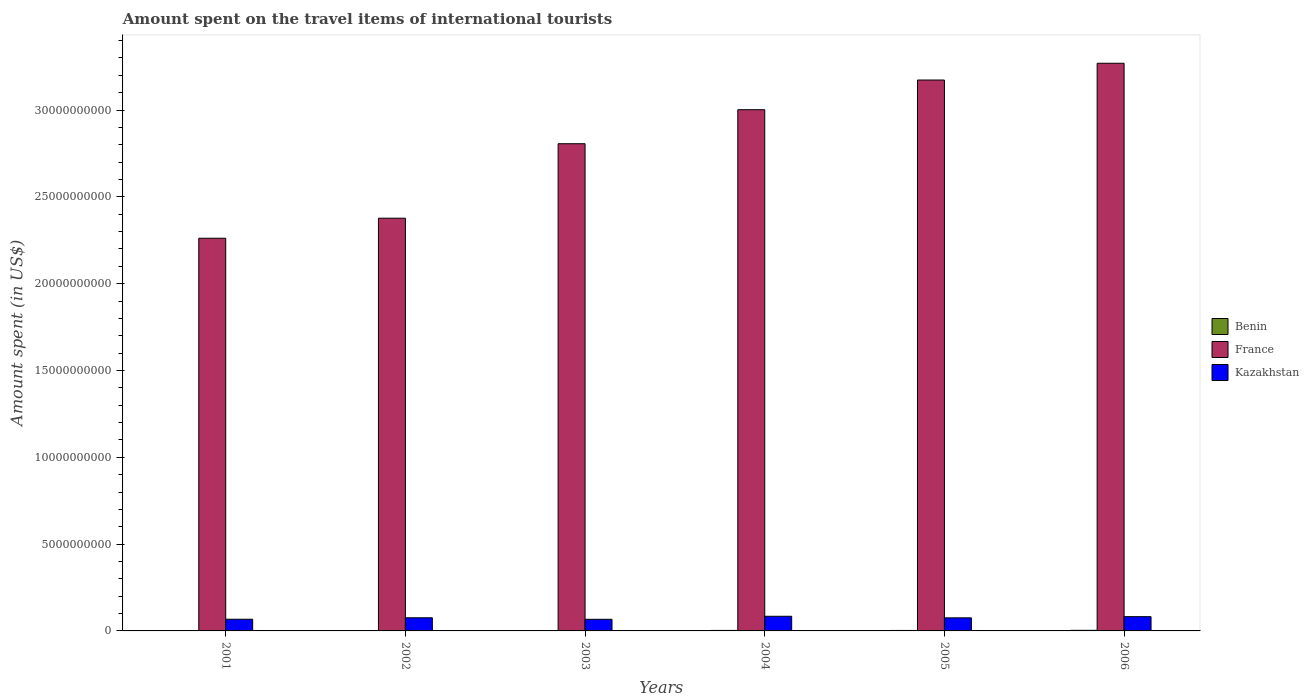How many groups of bars are there?
Provide a short and direct response. 6. Are the number of bars per tick equal to the number of legend labels?
Your answer should be compact. Yes. Are the number of bars on each tick of the X-axis equal?
Give a very brief answer. Yes. How many bars are there on the 3rd tick from the left?
Provide a succinct answer. 3. What is the label of the 2nd group of bars from the left?
Provide a short and direct response. 2002. In how many cases, is the number of bars for a given year not equal to the number of legend labels?
Make the answer very short. 0. What is the amount spent on the travel items of international tourists in France in 2002?
Make the answer very short. 2.38e+1. Across all years, what is the maximum amount spent on the travel items of international tourists in Kazakhstan?
Your answer should be very brief. 8.44e+08. Across all years, what is the minimum amount spent on the travel items of international tourists in Benin?
Provide a succinct answer. 1.70e+07. In which year was the amount spent on the travel items of international tourists in France minimum?
Ensure brevity in your answer.  2001. What is the total amount spent on the travel items of international tourists in Kazakhstan in the graph?
Offer a terse response. 4.52e+09. What is the difference between the amount spent on the travel items of international tourists in Benin in 2003 and that in 2004?
Offer a very short reply. -8.00e+06. What is the difference between the amount spent on the travel items of international tourists in Benin in 2005 and the amount spent on the travel items of international tourists in France in 2004?
Keep it short and to the point. -3.00e+1. What is the average amount spent on the travel items of international tourists in Kazakhstan per year?
Give a very brief answer. 7.53e+08. In the year 2005, what is the difference between the amount spent on the travel items of international tourists in Benin and amount spent on the travel items of international tourists in Kazakhstan?
Give a very brief answer. -7.26e+08. What is the ratio of the amount spent on the travel items of international tourists in France in 2001 to that in 2004?
Provide a short and direct response. 0.75. Is the amount spent on the travel items of international tourists in France in 2004 less than that in 2005?
Give a very brief answer. Yes. What is the difference between the highest and the second highest amount spent on the travel items of international tourists in Benin?
Make the answer very short. 5.00e+06. What is the difference between the highest and the lowest amount spent on the travel items of international tourists in Benin?
Offer a terse response. 1.70e+07. In how many years, is the amount spent on the travel items of international tourists in Benin greater than the average amount spent on the travel items of international tourists in Benin taken over all years?
Provide a short and direct response. 3. What does the 3rd bar from the left in 2003 represents?
Keep it short and to the point. Kazakhstan. What does the 1st bar from the right in 2004 represents?
Your response must be concise. Kazakhstan. How many bars are there?
Provide a short and direct response. 18. Are all the bars in the graph horizontal?
Your response must be concise. No. What is the difference between two consecutive major ticks on the Y-axis?
Give a very brief answer. 5.00e+09. Are the values on the major ticks of Y-axis written in scientific E-notation?
Provide a succinct answer. No. Does the graph contain any zero values?
Ensure brevity in your answer.  No. Does the graph contain grids?
Give a very brief answer. No. Where does the legend appear in the graph?
Provide a succinct answer. Center right. How many legend labels are there?
Keep it short and to the point. 3. What is the title of the graph?
Give a very brief answer. Amount spent on the travel items of international tourists. Does "Ireland" appear as one of the legend labels in the graph?
Give a very brief answer. No. What is the label or title of the Y-axis?
Your response must be concise. Amount spent (in US$). What is the Amount spent (in US$) of Benin in 2001?
Give a very brief answer. 1.70e+07. What is the Amount spent (in US$) of France in 2001?
Your answer should be compact. 2.26e+1. What is the Amount spent (in US$) in Kazakhstan in 2001?
Offer a terse response. 6.73e+08. What is the Amount spent (in US$) of France in 2002?
Make the answer very short. 2.38e+1. What is the Amount spent (in US$) of Kazakhstan in 2002?
Give a very brief answer. 7.57e+08. What is the Amount spent (in US$) in Benin in 2003?
Your response must be concise. 2.10e+07. What is the Amount spent (in US$) of France in 2003?
Your answer should be very brief. 2.81e+1. What is the Amount spent (in US$) of Kazakhstan in 2003?
Provide a succinct answer. 6.69e+08. What is the Amount spent (in US$) in Benin in 2004?
Your answer should be very brief. 2.90e+07. What is the Amount spent (in US$) of France in 2004?
Your answer should be compact. 3.00e+1. What is the Amount spent (in US$) in Kazakhstan in 2004?
Your response must be concise. 8.44e+08. What is the Amount spent (in US$) in Benin in 2005?
Your response must be concise. 2.70e+07. What is the Amount spent (in US$) of France in 2005?
Your answer should be compact. 3.17e+1. What is the Amount spent (in US$) of Kazakhstan in 2005?
Ensure brevity in your answer.  7.53e+08. What is the Amount spent (in US$) in Benin in 2006?
Provide a short and direct response. 3.40e+07. What is the Amount spent (in US$) of France in 2006?
Your answer should be very brief. 3.27e+1. What is the Amount spent (in US$) in Kazakhstan in 2006?
Provide a short and direct response. 8.21e+08. Across all years, what is the maximum Amount spent (in US$) of Benin?
Offer a very short reply. 3.40e+07. Across all years, what is the maximum Amount spent (in US$) of France?
Provide a succinct answer. 3.27e+1. Across all years, what is the maximum Amount spent (in US$) of Kazakhstan?
Give a very brief answer. 8.44e+08. Across all years, what is the minimum Amount spent (in US$) of Benin?
Provide a succinct answer. 1.70e+07. Across all years, what is the minimum Amount spent (in US$) in France?
Ensure brevity in your answer.  2.26e+1. Across all years, what is the minimum Amount spent (in US$) of Kazakhstan?
Give a very brief answer. 6.69e+08. What is the total Amount spent (in US$) of Benin in the graph?
Keep it short and to the point. 1.48e+08. What is the total Amount spent (in US$) of France in the graph?
Give a very brief answer. 1.69e+11. What is the total Amount spent (in US$) in Kazakhstan in the graph?
Offer a terse response. 4.52e+09. What is the difference between the Amount spent (in US$) of Benin in 2001 and that in 2002?
Your answer should be very brief. -3.00e+06. What is the difference between the Amount spent (in US$) of France in 2001 and that in 2002?
Keep it short and to the point. -1.15e+09. What is the difference between the Amount spent (in US$) in Kazakhstan in 2001 and that in 2002?
Offer a very short reply. -8.40e+07. What is the difference between the Amount spent (in US$) in France in 2001 and that in 2003?
Offer a terse response. -5.44e+09. What is the difference between the Amount spent (in US$) in Benin in 2001 and that in 2004?
Your response must be concise. -1.20e+07. What is the difference between the Amount spent (in US$) of France in 2001 and that in 2004?
Ensure brevity in your answer.  -7.40e+09. What is the difference between the Amount spent (in US$) in Kazakhstan in 2001 and that in 2004?
Ensure brevity in your answer.  -1.71e+08. What is the difference between the Amount spent (in US$) in Benin in 2001 and that in 2005?
Provide a short and direct response. -1.00e+07. What is the difference between the Amount spent (in US$) of France in 2001 and that in 2005?
Provide a succinct answer. -9.11e+09. What is the difference between the Amount spent (in US$) of Kazakhstan in 2001 and that in 2005?
Provide a succinct answer. -8.00e+07. What is the difference between the Amount spent (in US$) of Benin in 2001 and that in 2006?
Your answer should be very brief. -1.70e+07. What is the difference between the Amount spent (in US$) of France in 2001 and that in 2006?
Offer a very short reply. -1.01e+1. What is the difference between the Amount spent (in US$) in Kazakhstan in 2001 and that in 2006?
Your answer should be compact. -1.48e+08. What is the difference between the Amount spent (in US$) of France in 2002 and that in 2003?
Make the answer very short. -4.29e+09. What is the difference between the Amount spent (in US$) of Kazakhstan in 2002 and that in 2003?
Provide a succinct answer. 8.80e+07. What is the difference between the Amount spent (in US$) in Benin in 2002 and that in 2004?
Your answer should be compact. -9.00e+06. What is the difference between the Amount spent (in US$) in France in 2002 and that in 2004?
Give a very brief answer. -6.25e+09. What is the difference between the Amount spent (in US$) in Kazakhstan in 2002 and that in 2004?
Your answer should be compact. -8.70e+07. What is the difference between the Amount spent (in US$) in Benin in 2002 and that in 2005?
Your answer should be compact. -7.00e+06. What is the difference between the Amount spent (in US$) of France in 2002 and that in 2005?
Provide a succinct answer. -7.96e+09. What is the difference between the Amount spent (in US$) of Kazakhstan in 2002 and that in 2005?
Your response must be concise. 4.00e+06. What is the difference between the Amount spent (in US$) of Benin in 2002 and that in 2006?
Provide a succinct answer. -1.40e+07. What is the difference between the Amount spent (in US$) of France in 2002 and that in 2006?
Provide a short and direct response. -8.92e+09. What is the difference between the Amount spent (in US$) of Kazakhstan in 2002 and that in 2006?
Ensure brevity in your answer.  -6.40e+07. What is the difference between the Amount spent (in US$) of Benin in 2003 and that in 2004?
Provide a succinct answer. -8.00e+06. What is the difference between the Amount spent (in US$) in France in 2003 and that in 2004?
Provide a succinct answer. -1.96e+09. What is the difference between the Amount spent (in US$) of Kazakhstan in 2003 and that in 2004?
Your response must be concise. -1.75e+08. What is the difference between the Amount spent (in US$) in Benin in 2003 and that in 2005?
Provide a succinct answer. -6.00e+06. What is the difference between the Amount spent (in US$) of France in 2003 and that in 2005?
Give a very brief answer. -3.67e+09. What is the difference between the Amount spent (in US$) of Kazakhstan in 2003 and that in 2005?
Your answer should be compact. -8.40e+07. What is the difference between the Amount spent (in US$) in Benin in 2003 and that in 2006?
Provide a succinct answer. -1.30e+07. What is the difference between the Amount spent (in US$) of France in 2003 and that in 2006?
Your response must be concise. -4.63e+09. What is the difference between the Amount spent (in US$) in Kazakhstan in 2003 and that in 2006?
Ensure brevity in your answer.  -1.52e+08. What is the difference between the Amount spent (in US$) of France in 2004 and that in 2005?
Ensure brevity in your answer.  -1.71e+09. What is the difference between the Amount spent (in US$) of Kazakhstan in 2004 and that in 2005?
Your response must be concise. 9.10e+07. What is the difference between the Amount spent (in US$) of Benin in 2004 and that in 2006?
Give a very brief answer. -5.00e+06. What is the difference between the Amount spent (in US$) of France in 2004 and that in 2006?
Give a very brief answer. -2.68e+09. What is the difference between the Amount spent (in US$) in Kazakhstan in 2004 and that in 2006?
Your answer should be compact. 2.30e+07. What is the difference between the Amount spent (in US$) in Benin in 2005 and that in 2006?
Keep it short and to the point. -7.00e+06. What is the difference between the Amount spent (in US$) in France in 2005 and that in 2006?
Provide a short and direct response. -9.66e+08. What is the difference between the Amount spent (in US$) in Kazakhstan in 2005 and that in 2006?
Make the answer very short. -6.80e+07. What is the difference between the Amount spent (in US$) of Benin in 2001 and the Amount spent (in US$) of France in 2002?
Keep it short and to the point. -2.38e+1. What is the difference between the Amount spent (in US$) of Benin in 2001 and the Amount spent (in US$) of Kazakhstan in 2002?
Your response must be concise. -7.40e+08. What is the difference between the Amount spent (in US$) in France in 2001 and the Amount spent (in US$) in Kazakhstan in 2002?
Ensure brevity in your answer.  2.19e+1. What is the difference between the Amount spent (in US$) of Benin in 2001 and the Amount spent (in US$) of France in 2003?
Your answer should be very brief. -2.80e+1. What is the difference between the Amount spent (in US$) of Benin in 2001 and the Amount spent (in US$) of Kazakhstan in 2003?
Provide a succinct answer. -6.52e+08. What is the difference between the Amount spent (in US$) in France in 2001 and the Amount spent (in US$) in Kazakhstan in 2003?
Ensure brevity in your answer.  2.19e+1. What is the difference between the Amount spent (in US$) in Benin in 2001 and the Amount spent (in US$) in France in 2004?
Provide a short and direct response. -3.00e+1. What is the difference between the Amount spent (in US$) in Benin in 2001 and the Amount spent (in US$) in Kazakhstan in 2004?
Offer a terse response. -8.27e+08. What is the difference between the Amount spent (in US$) in France in 2001 and the Amount spent (in US$) in Kazakhstan in 2004?
Offer a terse response. 2.18e+1. What is the difference between the Amount spent (in US$) of Benin in 2001 and the Amount spent (in US$) of France in 2005?
Your response must be concise. -3.17e+1. What is the difference between the Amount spent (in US$) in Benin in 2001 and the Amount spent (in US$) in Kazakhstan in 2005?
Your answer should be very brief. -7.36e+08. What is the difference between the Amount spent (in US$) in France in 2001 and the Amount spent (in US$) in Kazakhstan in 2005?
Your answer should be compact. 2.19e+1. What is the difference between the Amount spent (in US$) in Benin in 2001 and the Amount spent (in US$) in France in 2006?
Provide a short and direct response. -3.27e+1. What is the difference between the Amount spent (in US$) of Benin in 2001 and the Amount spent (in US$) of Kazakhstan in 2006?
Make the answer very short. -8.04e+08. What is the difference between the Amount spent (in US$) of France in 2001 and the Amount spent (in US$) of Kazakhstan in 2006?
Ensure brevity in your answer.  2.18e+1. What is the difference between the Amount spent (in US$) of Benin in 2002 and the Amount spent (in US$) of France in 2003?
Provide a short and direct response. -2.80e+1. What is the difference between the Amount spent (in US$) of Benin in 2002 and the Amount spent (in US$) of Kazakhstan in 2003?
Make the answer very short. -6.49e+08. What is the difference between the Amount spent (in US$) of France in 2002 and the Amount spent (in US$) of Kazakhstan in 2003?
Your response must be concise. 2.31e+1. What is the difference between the Amount spent (in US$) in Benin in 2002 and the Amount spent (in US$) in France in 2004?
Make the answer very short. -3.00e+1. What is the difference between the Amount spent (in US$) of Benin in 2002 and the Amount spent (in US$) of Kazakhstan in 2004?
Your answer should be very brief. -8.24e+08. What is the difference between the Amount spent (in US$) in France in 2002 and the Amount spent (in US$) in Kazakhstan in 2004?
Make the answer very short. 2.29e+1. What is the difference between the Amount spent (in US$) of Benin in 2002 and the Amount spent (in US$) of France in 2005?
Your answer should be very brief. -3.17e+1. What is the difference between the Amount spent (in US$) of Benin in 2002 and the Amount spent (in US$) of Kazakhstan in 2005?
Offer a very short reply. -7.33e+08. What is the difference between the Amount spent (in US$) in France in 2002 and the Amount spent (in US$) in Kazakhstan in 2005?
Your answer should be compact. 2.30e+1. What is the difference between the Amount spent (in US$) of Benin in 2002 and the Amount spent (in US$) of France in 2006?
Provide a short and direct response. -3.27e+1. What is the difference between the Amount spent (in US$) of Benin in 2002 and the Amount spent (in US$) of Kazakhstan in 2006?
Offer a very short reply. -8.01e+08. What is the difference between the Amount spent (in US$) in France in 2002 and the Amount spent (in US$) in Kazakhstan in 2006?
Make the answer very short. 2.29e+1. What is the difference between the Amount spent (in US$) of Benin in 2003 and the Amount spent (in US$) of France in 2004?
Your answer should be compact. -3.00e+1. What is the difference between the Amount spent (in US$) in Benin in 2003 and the Amount spent (in US$) in Kazakhstan in 2004?
Ensure brevity in your answer.  -8.23e+08. What is the difference between the Amount spent (in US$) in France in 2003 and the Amount spent (in US$) in Kazakhstan in 2004?
Provide a short and direct response. 2.72e+1. What is the difference between the Amount spent (in US$) of Benin in 2003 and the Amount spent (in US$) of France in 2005?
Your answer should be very brief. -3.17e+1. What is the difference between the Amount spent (in US$) in Benin in 2003 and the Amount spent (in US$) in Kazakhstan in 2005?
Give a very brief answer. -7.32e+08. What is the difference between the Amount spent (in US$) of France in 2003 and the Amount spent (in US$) of Kazakhstan in 2005?
Your answer should be very brief. 2.73e+1. What is the difference between the Amount spent (in US$) in Benin in 2003 and the Amount spent (in US$) in France in 2006?
Make the answer very short. -3.27e+1. What is the difference between the Amount spent (in US$) in Benin in 2003 and the Amount spent (in US$) in Kazakhstan in 2006?
Ensure brevity in your answer.  -8.00e+08. What is the difference between the Amount spent (in US$) of France in 2003 and the Amount spent (in US$) of Kazakhstan in 2006?
Offer a terse response. 2.72e+1. What is the difference between the Amount spent (in US$) in Benin in 2004 and the Amount spent (in US$) in France in 2005?
Your answer should be compact. -3.17e+1. What is the difference between the Amount spent (in US$) in Benin in 2004 and the Amount spent (in US$) in Kazakhstan in 2005?
Your answer should be very brief. -7.24e+08. What is the difference between the Amount spent (in US$) of France in 2004 and the Amount spent (in US$) of Kazakhstan in 2005?
Your answer should be compact. 2.93e+1. What is the difference between the Amount spent (in US$) in Benin in 2004 and the Amount spent (in US$) in France in 2006?
Your answer should be compact. -3.27e+1. What is the difference between the Amount spent (in US$) in Benin in 2004 and the Amount spent (in US$) in Kazakhstan in 2006?
Your response must be concise. -7.92e+08. What is the difference between the Amount spent (in US$) of France in 2004 and the Amount spent (in US$) of Kazakhstan in 2006?
Offer a terse response. 2.92e+1. What is the difference between the Amount spent (in US$) in Benin in 2005 and the Amount spent (in US$) in France in 2006?
Your answer should be very brief. -3.27e+1. What is the difference between the Amount spent (in US$) of Benin in 2005 and the Amount spent (in US$) of Kazakhstan in 2006?
Your answer should be very brief. -7.94e+08. What is the difference between the Amount spent (in US$) of France in 2005 and the Amount spent (in US$) of Kazakhstan in 2006?
Provide a short and direct response. 3.09e+1. What is the average Amount spent (in US$) in Benin per year?
Your answer should be very brief. 2.47e+07. What is the average Amount spent (in US$) of France per year?
Ensure brevity in your answer.  2.81e+1. What is the average Amount spent (in US$) of Kazakhstan per year?
Offer a terse response. 7.53e+08. In the year 2001, what is the difference between the Amount spent (in US$) in Benin and Amount spent (in US$) in France?
Offer a very short reply. -2.26e+1. In the year 2001, what is the difference between the Amount spent (in US$) of Benin and Amount spent (in US$) of Kazakhstan?
Keep it short and to the point. -6.56e+08. In the year 2001, what is the difference between the Amount spent (in US$) of France and Amount spent (in US$) of Kazakhstan?
Your answer should be compact. 2.19e+1. In the year 2002, what is the difference between the Amount spent (in US$) of Benin and Amount spent (in US$) of France?
Your response must be concise. -2.37e+1. In the year 2002, what is the difference between the Amount spent (in US$) in Benin and Amount spent (in US$) in Kazakhstan?
Make the answer very short. -7.37e+08. In the year 2002, what is the difference between the Amount spent (in US$) in France and Amount spent (in US$) in Kazakhstan?
Offer a terse response. 2.30e+1. In the year 2003, what is the difference between the Amount spent (in US$) in Benin and Amount spent (in US$) in France?
Provide a succinct answer. -2.80e+1. In the year 2003, what is the difference between the Amount spent (in US$) in Benin and Amount spent (in US$) in Kazakhstan?
Your answer should be compact. -6.48e+08. In the year 2003, what is the difference between the Amount spent (in US$) in France and Amount spent (in US$) in Kazakhstan?
Provide a short and direct response. 2.74e+1. In the year 2004, what is the difference between the Amount spent (in US$) in Benin and Amount spent (in US$) in France?
Provide a succinct answer. -3.00e+1. In the year 2004, what is the difference between the Amount spent (in US$) of Benin and Amount spent (in US$) of Kazakhstan?
Give a very brief answer. -8.15e+08. In the year 2004, what is the difference between the Amount spent (in US$) in France and Amount spent (in US$) in Kazakhstan?
Keep it short and to the point. 2.92e+1. In the year 2005, what is the difference between the Amount spent (in US$) in Benin and Amount spent (in US$) in France?
Provide a short and direct response. -3.17e+1. In the year 2005, what is the difference between the Amount spent (in US$) of Benin and Amount spent (in US$) of Kazakhstan?
Offer a very short reply. -7.26e+08. In the year 2005, what is the difference between the Amount spent (in US$) in France and Amount spent (in US$) in Kazakhstan?
Offer a terse response. 3.10e+1. In the year 2006, what is the difference between the Amount spent (in US$) of Benin and Amount spent (in US$) of France?
Provide a succinct answer. -3.27e+1. In the year 2006, what is the difference between the Amount spent (in US$) of Benin and Amount spent (in US$) of Kazakhstan?
Make the answer very short. -7.87e+08. In the year 2006, what is the difference between the Amount spent (in US$) in France and Amount spent (in US$) in Kazakhstan?
Keep it short and to the point. 3.19e+1. What is the ratio of the Amount spent (in US$) in Benin in 2001 to that in 2002?
Your answer should be compact. 0.85. What is the ratio of the Amount spent (in US$) in France in 2001 to that in 2002?
Keep it short and to the point. 0.95. What is the ratio of the Amount spent (in US$) of Kazakhstan in 2001 to that in 2002?
Your answer should be very brief. 0.89. What is the ratio of the Amount spent (in US$) in Benin in 2001 to that in 2003?
Your answer should be compact. 0.81. What is the ratio of the Amount spent (in US$) in France in 2001 to that in 2003?
Your response must be concise. 0.81. What is the ratio of the Amount spent (in US$) of Benin in 2001 to that in 2004?
Offer a very short reply. 0.59. What is the ratio of the Amount spent (in US$) of France in 2001 to that in 2004?
Your answer should be very brief. 0.75. What is the ratio of the Amount spent (in US$) of Kazakhstan in 2001 to that in 2004?
Provide a succinct answer. 0.8. What is the ratio of the Amount spent (in US$) of Benin in 2001 to that in 2005?
Provide a short and direct response. 0.63. What is the ratio of the Amount spent (in US$) in France in 2001 to that in 2005?
Offer a very short reply. 0.71. What is the ratio of the Amount spent (in US$) in Kazakhstan in 2001 to that in 2005?
Your response must be concise. 0.89. What is the ratio of the Amount spent (in US$) in France in 2001 to that in 2006?
Give a very brief answer. 0.69. What is the ratio of the Amount spent (in US$) of Kazakhstan in 2001 to that in 2006?
Ensure brevity in your answer.  0.82. What is the ratio of the Amount spent (in US$) in France in 2002 to that in 2003?
Provide a succinct answer. 0.85. What is the ratio of the Amount spent (in US$) in Kazakhstan in 2002 to that in 2003?
Your answer should be very brief. 1.13. What is the ratio of the Amount spent (in US$) of Benin in 2002 to that in 2004?
Your response must be concise. 0.69. What is the ratio of the Amount spent (in US$) of France in 2002 to that in 2004?
Offer a terse response. 0.79. What is the ratio of the Amount spent (in US$) of Kazakhstan in 2002 to that in 2004?
Your answer should be very brief. 0.9. What is the ratio of the Amount spent (in US$) in Benin in 2002 to that in 2005?
Make the answer very short. 0.74. What is the ratio of the Amount spent (in US$) of France in 2002 to that in 2005?
Your answer should be very brief. 0.75. What is the ratio of the Amount spent (in US$) of Benin in 2002 to that in 2006?
Give a very brief answer. 0.59. What is the ratio of the Amount spent (in US$) of France in 2002 to that in 2006?
Your response must be concise. 0.73. What is the ratio of the Amount spent (in US$) in Kazakhstan in 2002 to that in 2006?
Provide a succinct answer. 0.92. What is the ratio of the Amount spent (in US$) in Benin in 2003 to that in 2004?
Provide a succinct answer. 0.72. What is the ratio of the Amount spent (in US$) in France in 2003 to that in 2004?
Ensure brevity in your answer.  0.93. What is the ratio of the Amount spent (in US$) of Kazakhstan in 2003 to that in 2004?
Provide a succinct answer. 0.79. What is the ratio of the Amount spent (in US$) of France in 2003 to that in 2005?
Your response must be concise. 0.88. What is the ratio of the Amount spent (in US$) in Kazakhstan in 2003 to that in 2005?
Your response must be concise. 0.89. What is the ratio of the Amount spent (in US$) in Benin in 2003 to that in 2006?
Offer a terse response. 0.62. What is the ratio of the Amount spent (in US$) in France in 2003 to that in 2006?
Make the answer very short. 0.86. What is the ratio of the Amount spent (in US$) of Kazakhstan in 2003 to that in 2006?
Keep it short and to the point. 0.81. What is the ratio of the Amount spent (in US$) of Benin in 2004 to that in 2005?
Offer a very short reply. 1.07. What is the ratio of the Amount spent (in US$) in France in 2004 to that in 2005?
Offer a terse response. 0.95. What is the ratio of the Amount spent (in US$) in Kazakhstan in 2004 to that in 2005?
Your answer should be compact. 1.12. What is the ratio of the Amount spent (in US$) of Benin in 2004 to that in 2006?
Your response must be concise. 0.85. What is the ratio of the Amount spent (in US$) in France in 2004 to that in 2006?
Your answer should be very brief. 0.92. What is the ratio of the Amount spent (in US$) in Kazakhstan in 2004 to that in 2006?
Make the answer very short. 1.03. What is the ratio of the Amount spent (in US$) in Benin in 2005 to that in 2006?
Make the answer very short. 0.79. What is the ratio of the Amount spent (in US$) of France in 2005 to that in 2006?
Your answer should be compact. 0.97. What is the ratio of the Amount spent (in US$) in Kazakhstan in 2005 to that in 2006?
Provide a succinct answer. 0.92. What is the difference between the highest and the second highest Amount spent (in US$) of France?
Offer a terse response. 9.66e+08. What is the difference between the highest and the second highest Amount spent (in US$) of Kazakhstan?
Your answer should be compact. 2.30e+07. What is the difference between the highest and the lowest Amount spent (in US$) of Benin?
Offer a very short reply. 1.70e+07. What is the difference between the highest and the lowest Amount spent (in US$) of France?
Keep it short and to the point. 1.01e+1. What is the difference between the highest and the lowest Amount spent (in US$) in Kazakhstan?
Offer a terse response. 1.75e+08. 